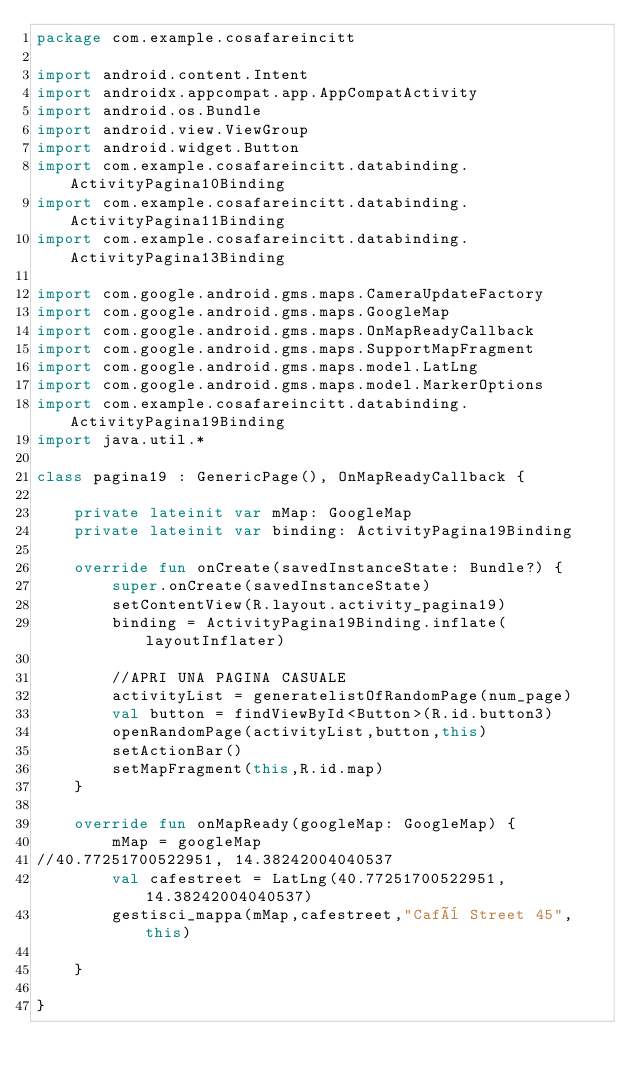Convert code to text. <code><loc_0><loc_0><loc_500><loc_500><_Kotlin_>package com.example.cosafareincitt

import android.content.Intent
import androidx.appcompat.app.AppCompatActivity
import android.os.Bundle
import android.view.ViewGroup
import android.widget.Button
import com.example.cosafareincitt.databinding.ActivityPagina10Binding
import com.example.cosafareincitt.databinding.ActivityPagina11Binding
import com.example.cosafareincitt.databinding.ActivityPagina13Binding

import com.google.android.gms.maps.CameraUpdateFactory
import com.google.android.gms.maps.GoogleMap
import com.google.android.gms.maps.OnMapReadyCallback
import com.google.android.gms.maps.SupportMapFragment
import com.google.android.gms.maps.model.LatLng
import com.google.android.gms.maps.model.MarkerOptions
import com.example.cosafareincitt.databinding.ActivityPagina19Binding
import java.util.*

class pagina19 : GenericPage(), OnMapReadyCallback {

    private lateinit var mMap: GoogleMap
    private lateinit var binding: ActivityPagina19Binding

    override fun onCreate(savedInstanceState: Bundle?) {
        super.onCreate(savedInstanceState)
        setContentView(R.layout.activity_pagina19)
        binding = ActivityPagina19Binding.inflate(layoutInflater)

        //APRI UNA PAGINA CASUALE
        activityList = generatelistOfRandomPage(num_page)
        val button = findViewById<Button>(R.id.button3)
        openRandomPage(activityList,button,this)
        setActionBar()
        setMapFragment(this,R.id.map)
    }

    override fun onMapReady(googleMap: GoogleMap) {
        mMap = googleMap
//40.77251700522951, 14.38242004040537
        val cafestreet = LatLng(40.77251700522951, 14.38242004040537)
        gestisci_mappa(mMap,cafestreet,"Cafè Street 45",this)

    }

}</code> 